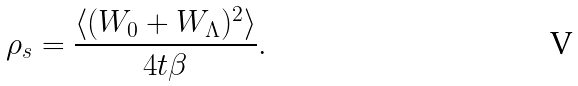<formula> <loc_0><loc_0><loc_500><loc_500>\rho _ { s } = \frac { \langle ( W _ { 0 } + W _ { \Lambda } ) ^ { 2 } \rangle } { 4 t \beta } .</formula> 